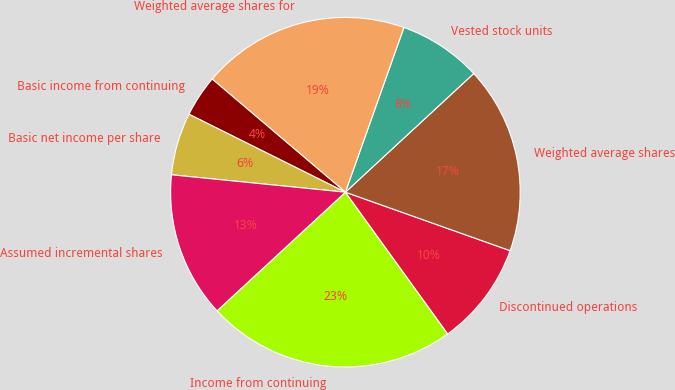Convert chart to OTSL. <chart><loc_0><loc_0><loc_500><loc_500><pie_chart><fcel>Income from continuing<fcel>Discontinued operations<fcel>Weighted average shares<fcel>Vested stock units<fcel>Weighted average shares for<fcel>Basic income from continuing<fcel>Basic net income per share<fcel>Assumed incremental shares<nl><fcel>23.08%<fcel>9.62%<fcel>17.31%<fcel>7.69%<fcel>19.23%<fcel>3.85%<fcel>5.77%<fcel>13.46%<nl></chart> 